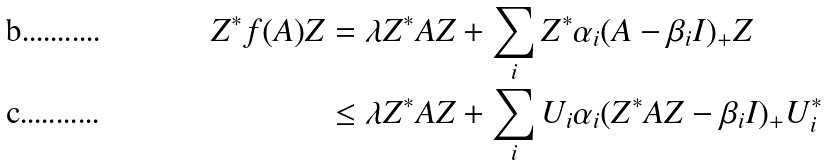<formula> <loc_0><loc_0><loc_500><loc_500>Z ^ { * } f ( A ) Z & = \lambda Z ^ { * } A Z + \sum _ { i } Z ^ { * } \alpha _ { i } ( A - \beta _ { i } I ) _ { + } Z \\ & \leq \lambda Z ^ { * } A Z + \sum _ { i } U _ { i } \alpha _ { i } ( Z ^ { * } A Z - \beta _ { i } I ) _ { + } U _ { i } ^ { * }</formula> 